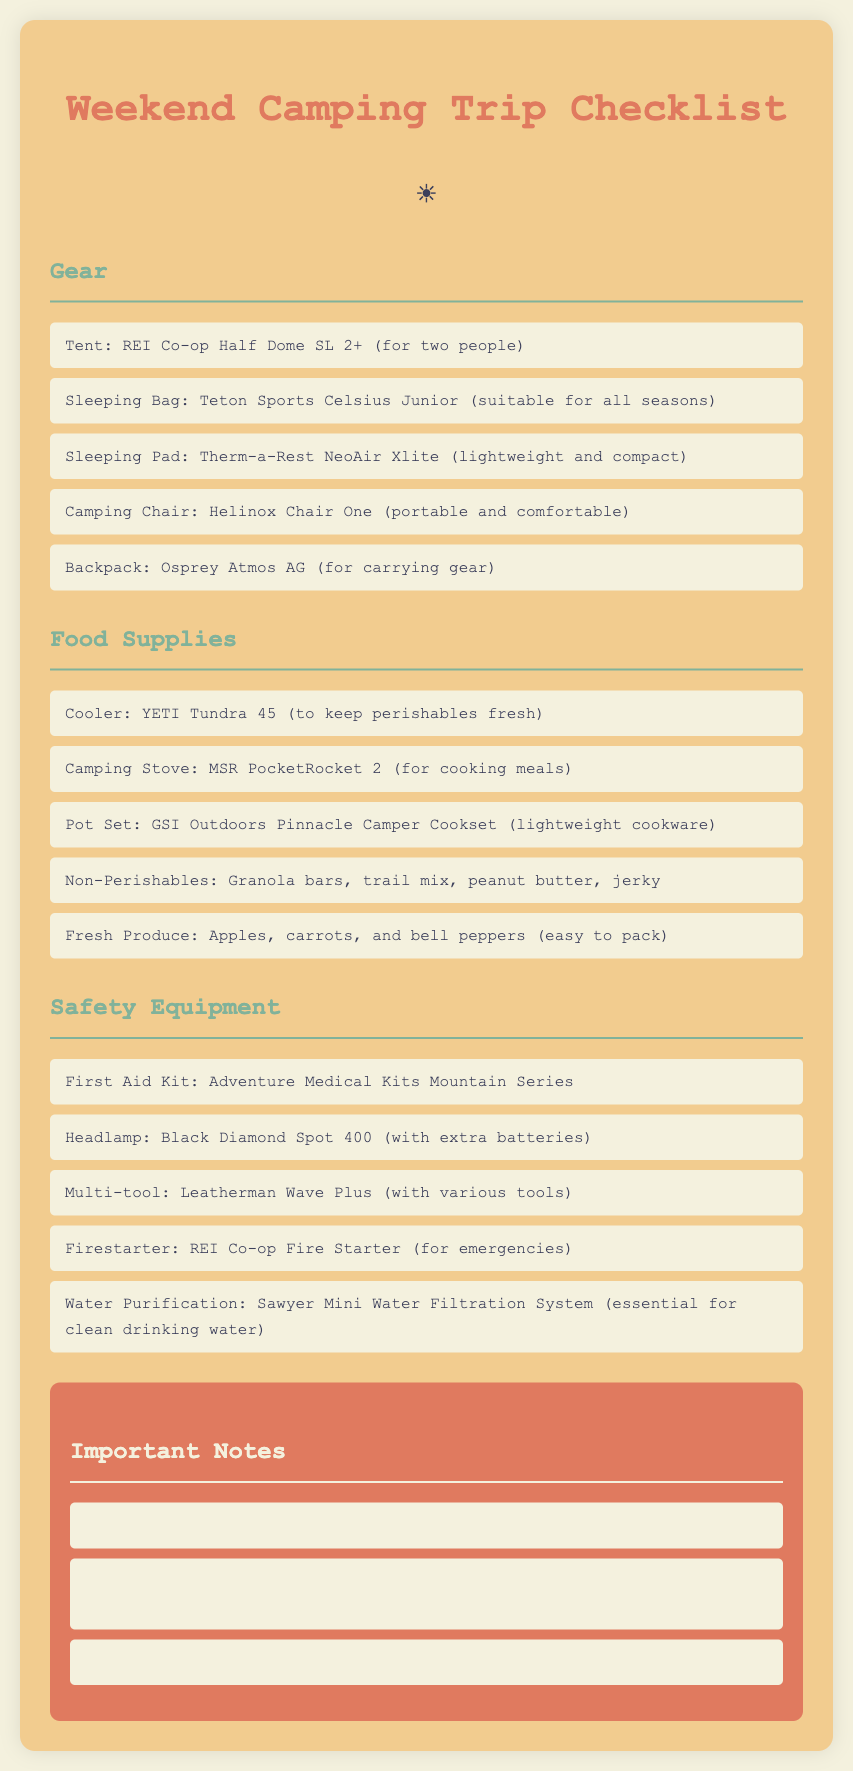What is the name of the camping stove? The name of the camping stove listed is MSR PocketRocket 2.
Answer: MSR PocketRocket 2 How many people can the tent accommodate? The tent mentioned can accommodate two people.
Answer: two people What is the brand of the sleeping pad? The brand of the sleeping pad mentioned is Therm-a-Rest.
Answer: Therm-a-Rest What is a recommended food supply that is easily packable? Apples, carrots, and bell peppers are recommended as they are easy to pack.
Answer: Apples, carrots, and bell peppers Which safety equipment is essential for clean drinking water? Sawyer Mini Water Filtration System is essential for clean drinking water.
Answer: Sawyer Mini Water Filtration System Why should you include sunscreen? Sunscreen should be included to protect your skin while outdoors in the sun.
Answer: to protect your skin What is one item mentioned for starting a fire? REI Co-op Fire Starter is mentioned for starting a fire.
Answer: REI Co-op Fire Starter How many items are listed under Gear? There are five items listed under Gear.
Answer: five What should you do before going camping? You should check weather conditions and pack accordingly.
Answer: check weather conditions 